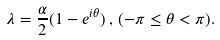<formula> <loc_0><loc_0><loc_500><loc_500>\lambda = \frac { \alpha } { 2 } ( 1 - e ^ { i \theta } ) \, , \, ( - \pi \leq \theta < \pi ) .</formula> 